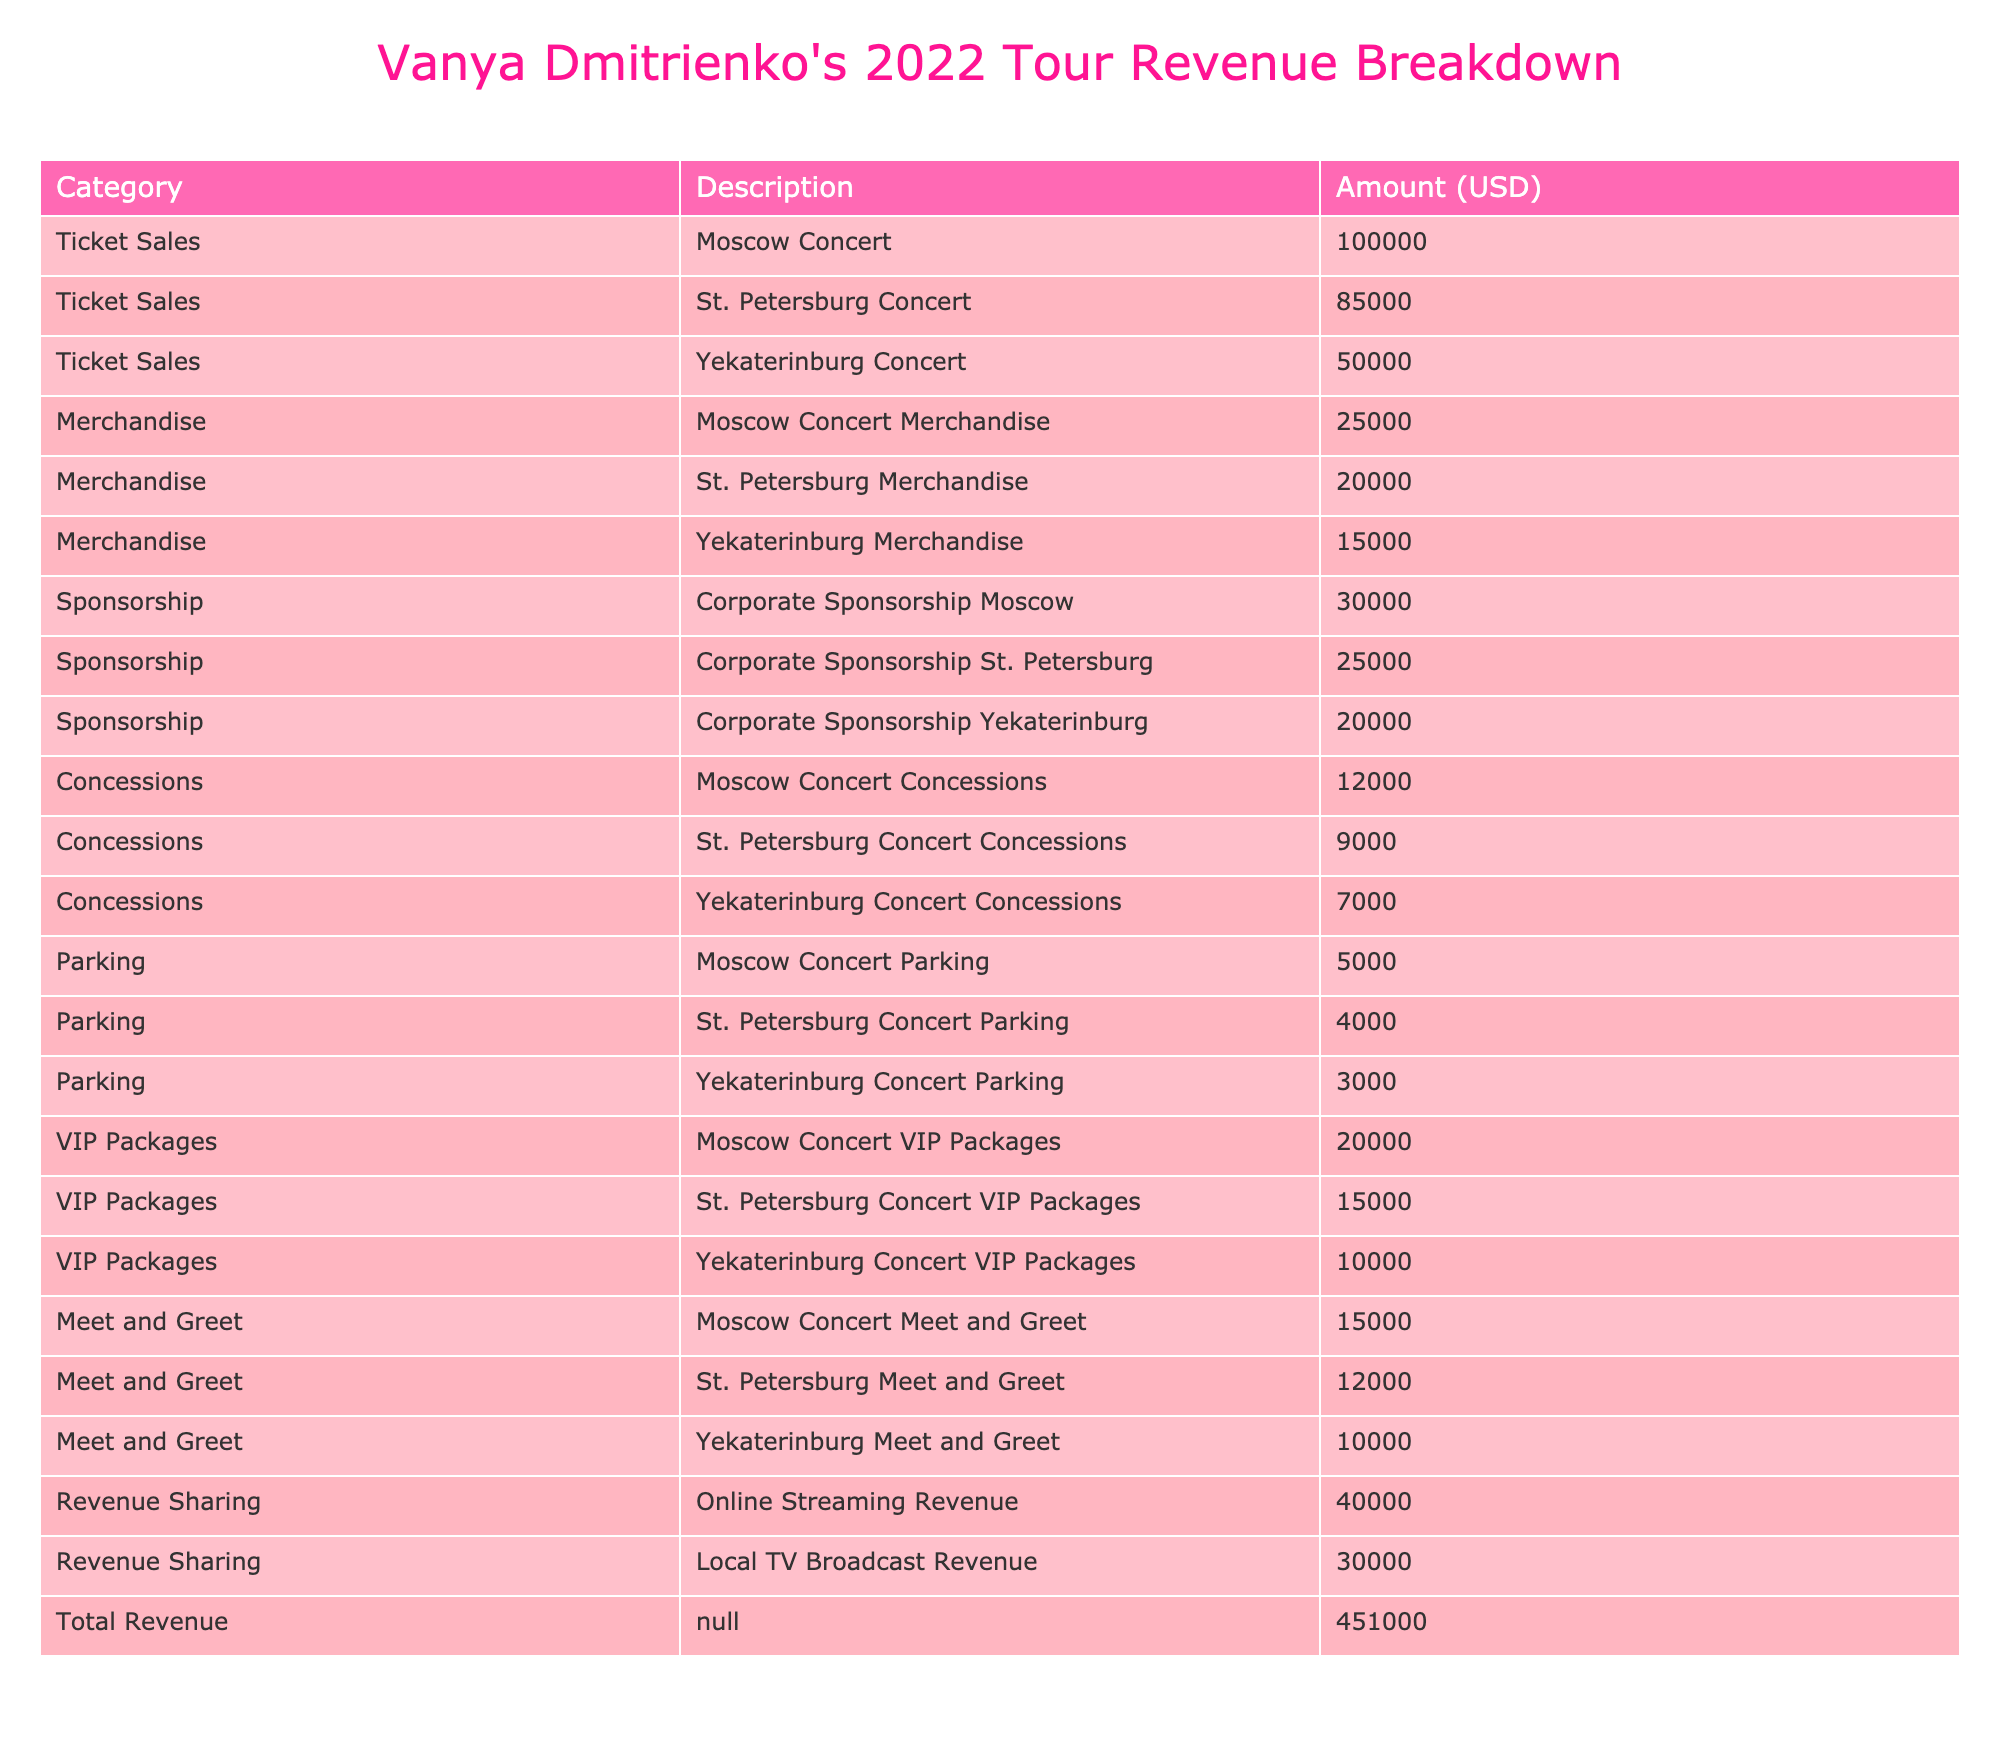What is the total revenue generated from the concerts? The table shows a "Total Revenue" row with an "Amount (USD)" value of $451,000. This value represents the overall earnings from all the categories combined.
Answer: 451000 Which concert generated the highest revenue from ticket sales? In the "Ticket Sales" category, the "Moscow Concert" has the highest amount of $100,000, compared to the other cities listed.
Answer: 100000 What is the combined revenue from merchandise sold at all concerts? By adding the amounts from the merchandise rows: Moscow Concert Merchandise ($25,000) + St. Petersburg Merchandise ($20,000) + Yekaterinburg Merchandise ($15,000) = $60,000.
Answer: 60000 Did the St. Petersburg Concert generate more revenue from concessions than the Yekaterinburg Concert? In the "Concessions" category, St. Petersburg Concert Concessions earned $9,000 while Yekaterinburg Concert Concessions earned only $7,000. Therefore, St. Petersburg generated more revenue in this category.
Answer: Yes What was the total revenue from all VIP packages across the concerts? The "VIP Packages" total includes $20,000 from Moscow, $15,000 from St. Petersburg, and $10,000 from Yekaterinburg. Adding these gives: $20,000 + $15,000 + $10,000 = $45,000.
Answer: 45000 Is the revenue from online streaming higher than that of local TV broadcasts? The "Revenue Sharing" category shows $40,000 for online streaming and $30,000 for local TV broadcasts. Since $40,000 is greater than $30,000, the answer is yes.
Answer: Yes What is the average revenue per concert from the merchandise category? There are three concerts with merchandise revenues of $25,000, $20,000, and $15,000. The total is $60,000, and divided by three concerts gives an average of $60,000 / 3 = $20,000.
Answer: 20000 What is the total revenue from all categories combined for the Moscow concert? For the Moscow concert, we need to sum these categories: Ticket Sales ($100,000) + Merchandise ($25,000) + Sponsorship ($30,000) + Concessions ($12,000) + Parking ($5,000) + VIP Packages ($20,000) + Meet and Greet ($15,000). The total is $100,000 + $25,000 + $30,000 + $12,000 + $5,000 + $20,000 + $15,000 = $207,000.
Answer: 207000 Which category contributed the least amount to the total revenue? The "Parking" category for Yekaterinburg Concert Parking is the lowest with $3,000. All other categories have higher amounts.
Answer: 3000 